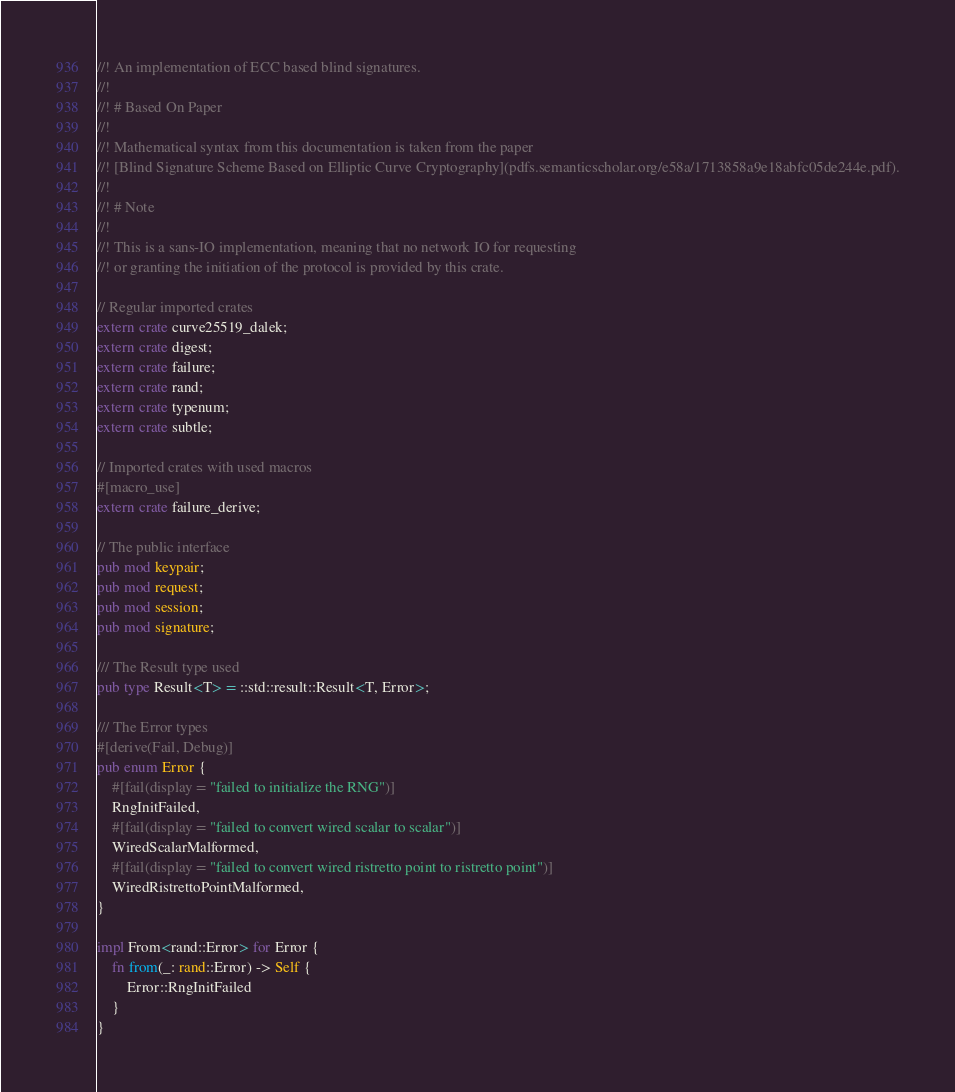Convert code to text. <code><loc_0><loc_0><loc_500><loc_500><_Rust_>//! An implementation of ECC based blind signatures.
//!
//! # Based On Paper
//!
//! Mathematical syntax from this documentation is taken from the paper
//! [Blind Signature Scheme Based on Elliptic Curve Cryptography](pdfs.semanticscholar.org/e58a/1713858a9e18abfc05de244e.pdf).
//!
//! # Note
//!
//! This is a sans-IO implementation, meaning that no network IO for requesting
//! or granting the initiation of the protocol is provided by this crate.

// Regular imported crates
extern crate curve25519_dalek;
extern crate digest;
extern crate failure;
extern crate rand;
extern crate typenum;
extern crate subtle;

// Imported crates with used macros
#[macro_use]
extern crate failure_derive;

// The public interface
pub mod keypair;
pub mod request;
pub mod session;
pub mod signature;

/// The Result type used
pub type Result<T> = ::std::result::Result<T, Error>;

/// The Error types
#[derive(Fail, Debug)]
pub enum Error {
    #[fail(display = "failed to initialize the RNG")]
    RngInitFailed,
    #[fail(display = "failed to convert wired scalar to scalar")]
    WiredScalarMalformed,
    #[fail(display = "failed to convert wired ristretto point to ristretto point")]
    WiredRistrettoPointMalformed,
}

impl From<rand::Error> for Error {
    fn from(_: rand::Error) -> Self {
        Error::RngInitFailed
    }
}
</code> 